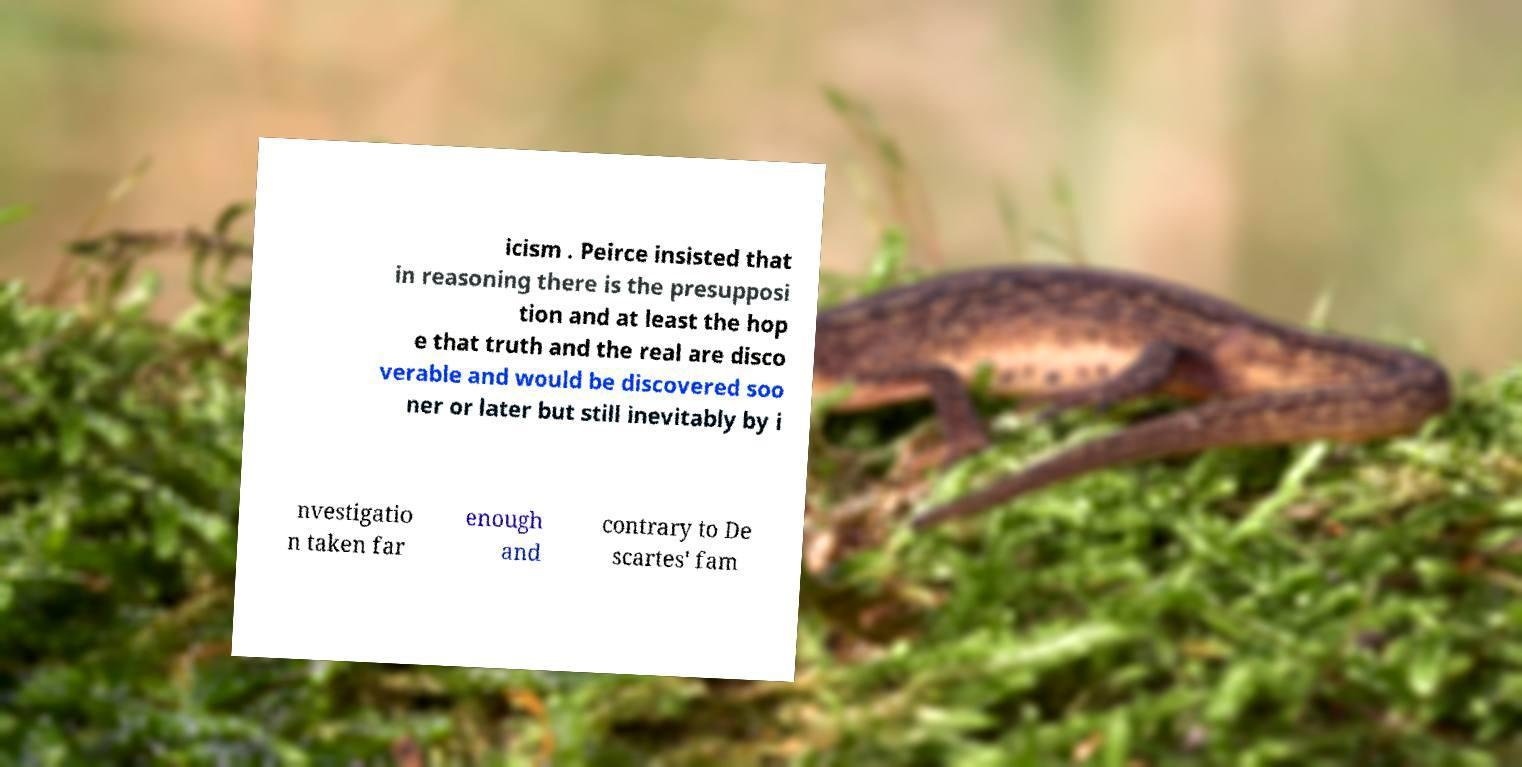What messages or text are displayed in this image? I need them in a readable, typed format. icism . Peirce insisted that in reasoning there is the presupposi tion and at least the hop e that truth and the real are disco verable and would be discovered soo ner or later but still inevitably by i nvestigatio n taken far enough and contrary to De scartes' fam 